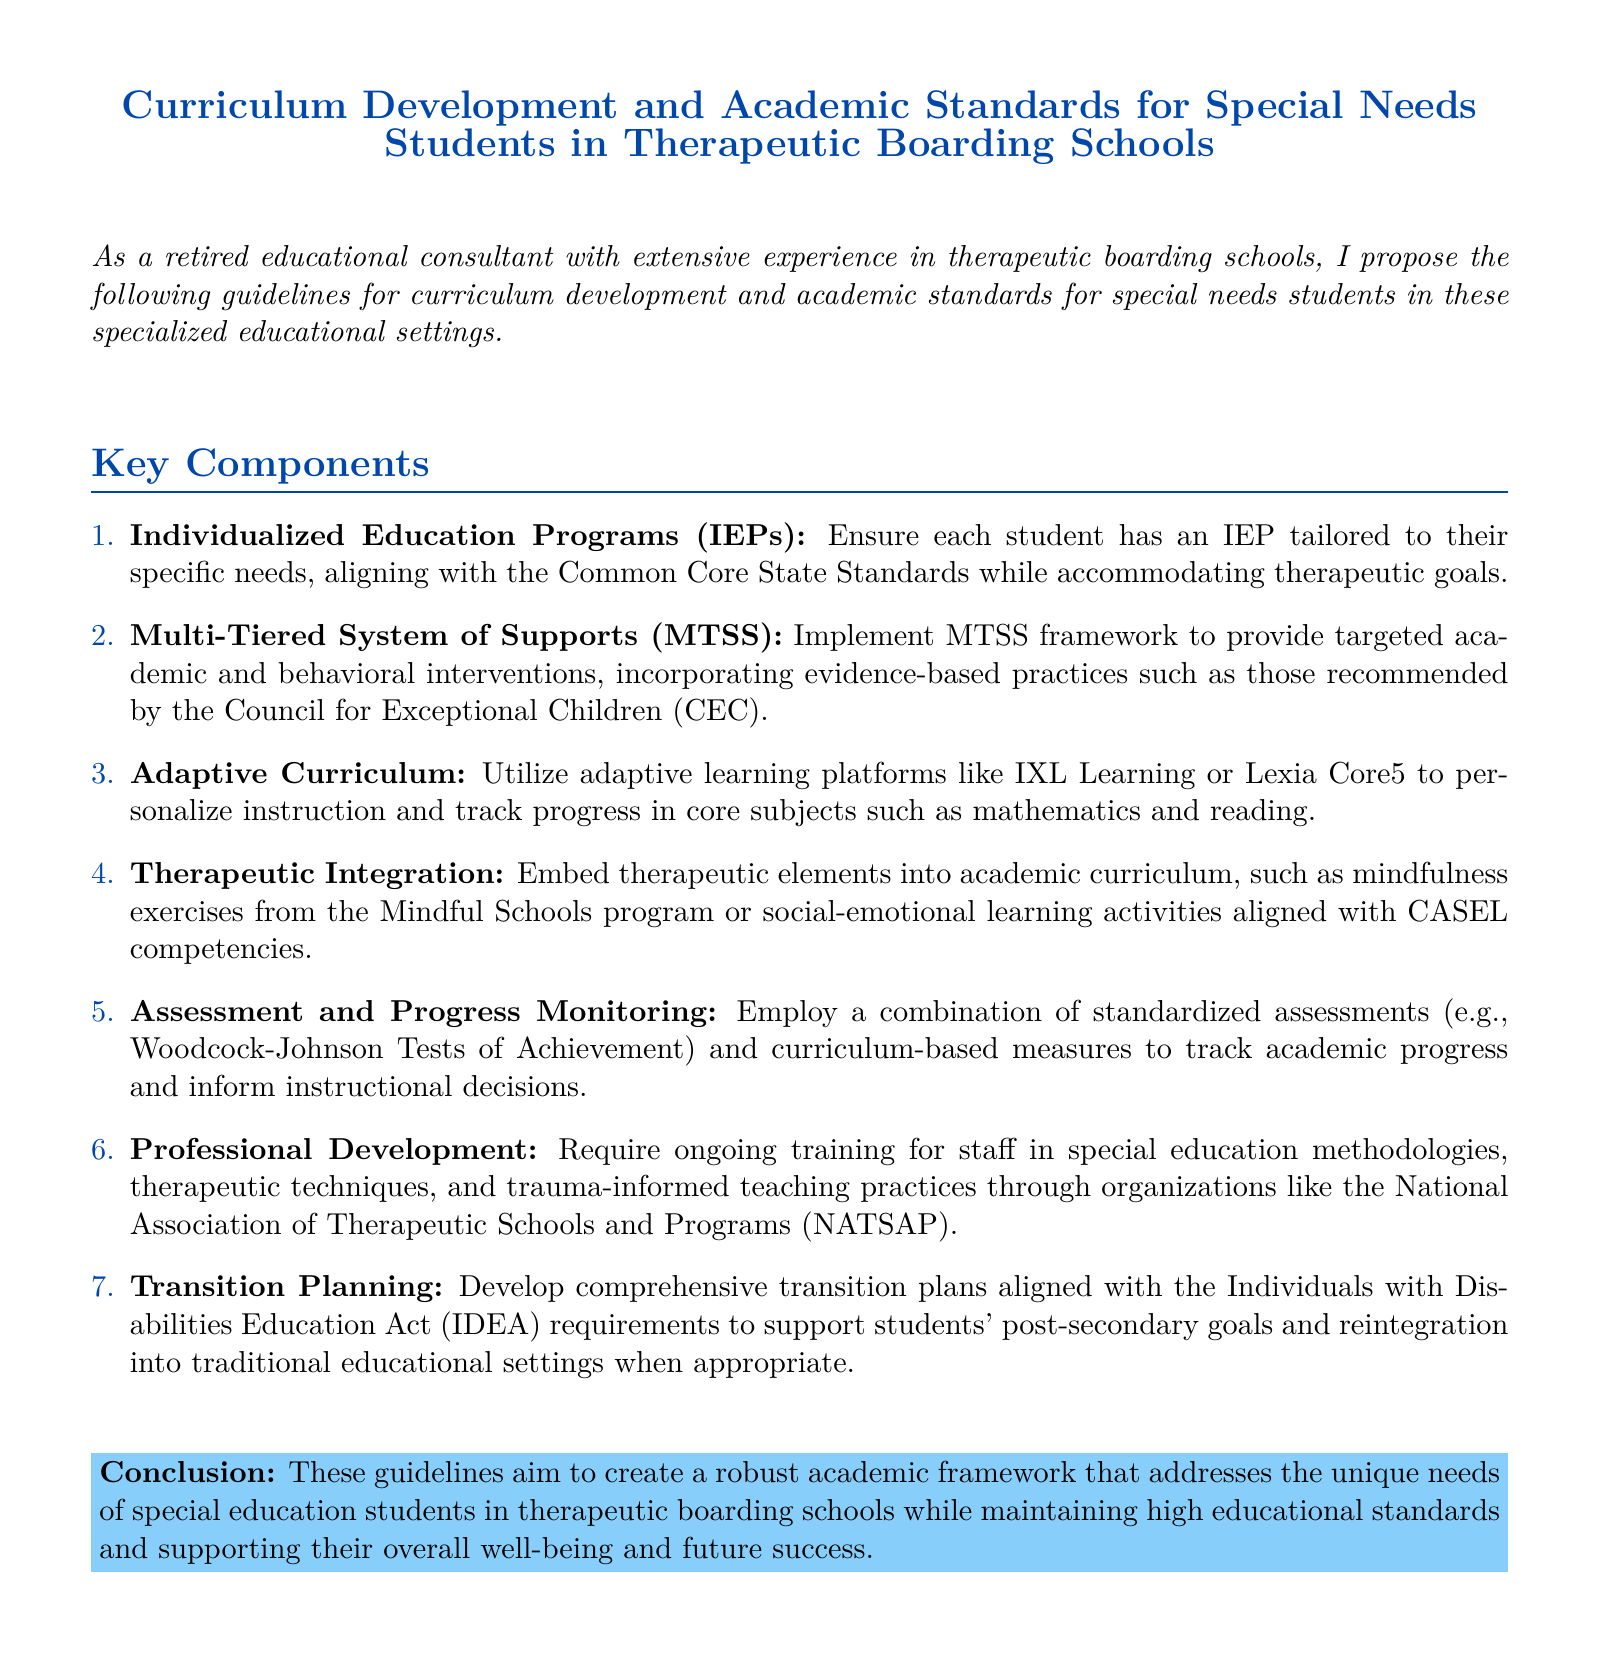What is the main title of the document? The title summarizes the focus of the document, which is centered on curriculum and academic standards for special needs students.
Answer: Curriculum Development and Academic Standards for Special Needs Students in Therapeutic Boarding Schools What framework does the document suggest for academic and behavioral interventions? The document refers to a structured approach aimed at supporting students, which is critical in therapeutic education settings.
Answer: Multi-Tiered System of Supports (MTSS) What type of programs must each student have according to the document? The requirement emphasizes the importance of a personalized educational approach for each student's needs.
Answer: Individualized Education Programs (IEPs) Which organization is mentioned for ongoing staff training? This organization focuses on therapeutic schools and training for staff, crucial for implementing effective educational methods.
Answer: National Association of Therapeutic Schools and Programs (NATSAP) How many key components are outlined in the document? The total number of components provides insight into the comprehensive nature of the guidelines.
Answer: 7 What kind of curriculum does the document propose utilizing? The document specifies a type of instructional approach that adapts learning to fit individual student needs.
Answer: Adaptive Curriculum What is the purpose of the transition planning mentioned? This planning process is essential for preparing students for life after therapeutic schooling, in alignment with federal requirements.
Answer: Post-secondary goals and reintegration What assessment tools are recommended in the document? The specific tools highlight the methods for evaluating academic progress in special needs education.
Answer: Woodcock-Johnson Tests of Achievement 